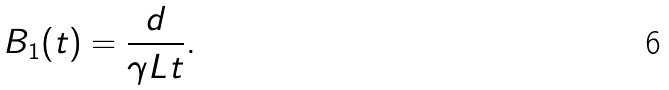<formula> <loc_0><loc_0><loc_500><loc_500>B _ { 1 } ( t ) = \frac { d } { \gamma L t } .</formula> 